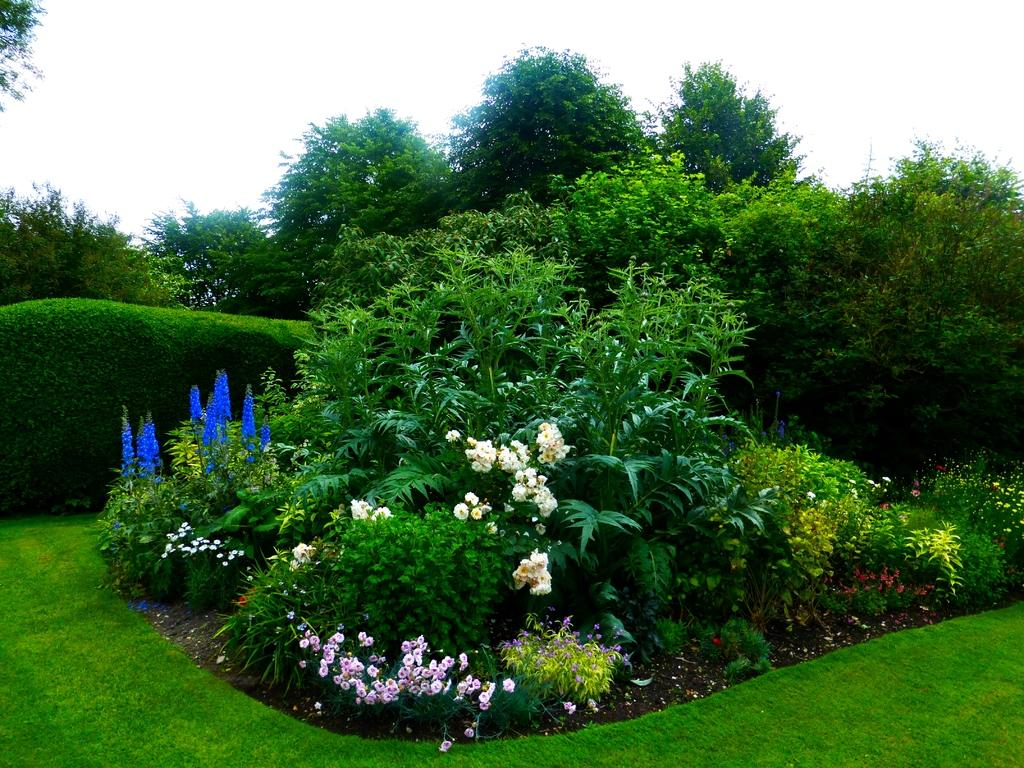What type of plants can be seen in the image? There are plants with flowers in the image. What is the ground covered with? The ground is covered in greenery. What can be seen in the background of the image? There are trees in the background of the image. Where is the beggar standing in the image? There is no beggar present in the image. What type of market can be seen in the image? There is no market present in the image. 